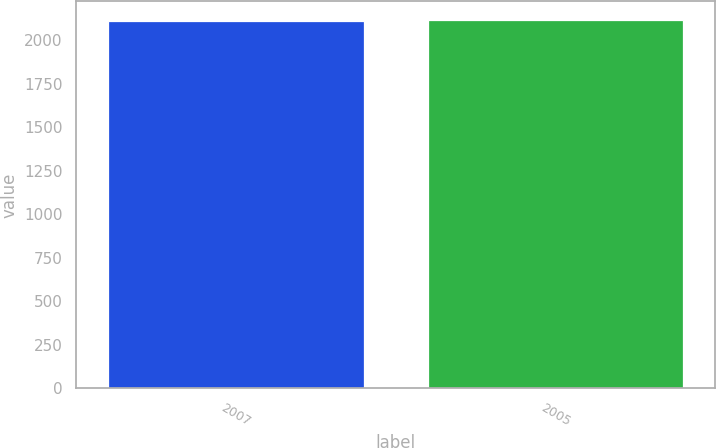<chart> <loc_0><loc_0><loc_500><loc_500><bar_chart><fcel>2007<fcel>2005<nl><fcel>2108.3<fcel>2115<nl></chart> 